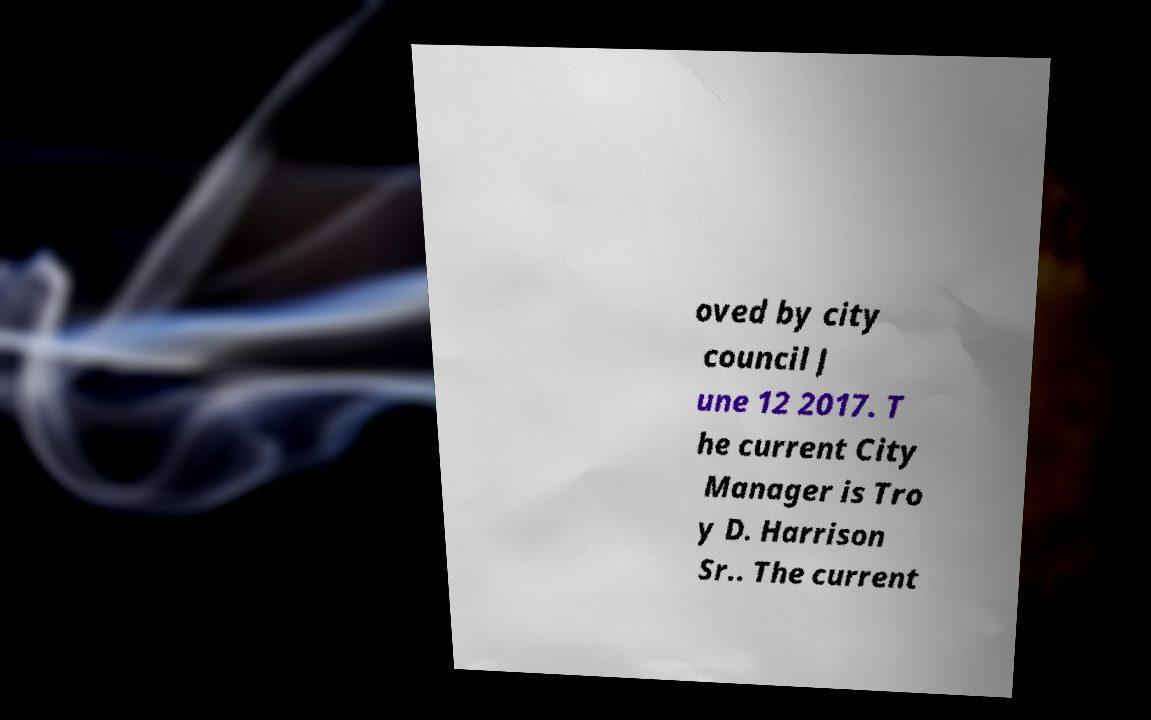Please identify and transcribe the text found in this image. oved by city council J une 12 2017. T he current City Manager is Tro y D. Harrison Sr.. The current 